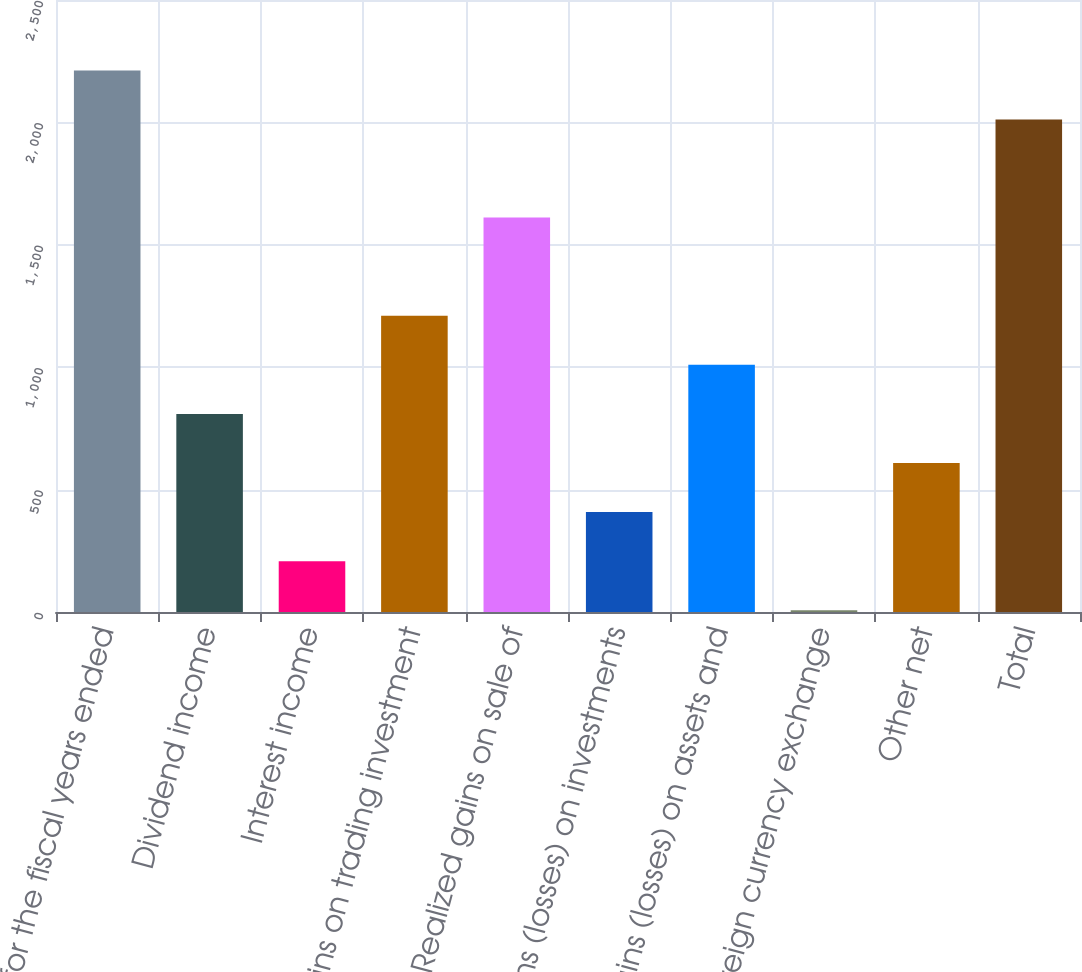Convert chart. <chart><loc_0><loc_0><loc_500><loc_500><bar_chart><fcel>for the fiscal years ended<fcel>Dividend income<fcel>Interest income<fcel>Gains on trading investment<fcel>Realized gains on sale of<fcel>Gains (losses) on investments<fcel>Gains (losses) on assets and<fcel>Foreign currency exchange<fcel>Other net<fcel>Total<nl><fcel>2212.49<fcel>809.06<fcel>207.59<fcel>1210.04<fcel>1611.02<fcel>408.08<fcel>1009.55<fcel>7.1<fcel>608.57<fcel>2012<nl></chart> 